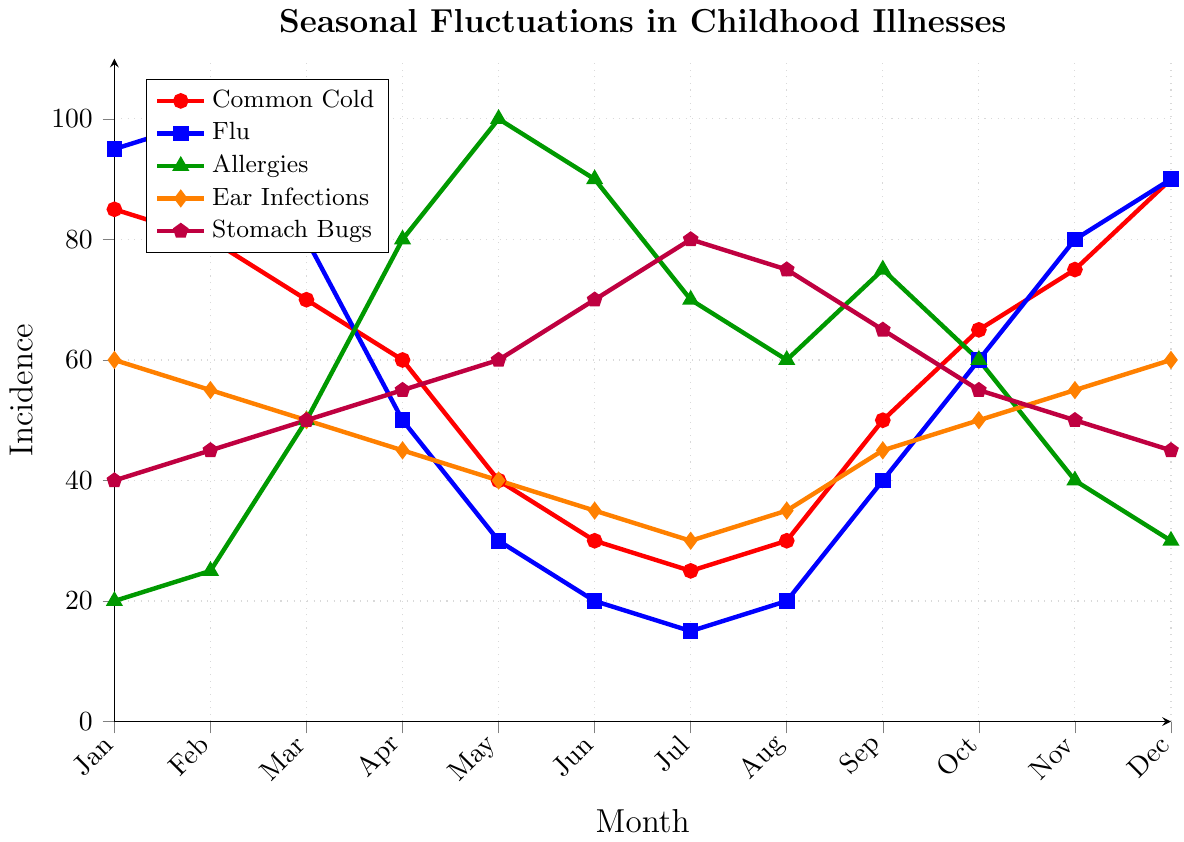Which illness has the highest incidence in February? Look for the peak points in February. The illness with the highest value is the one with the highest incidence. The Flu reaches 100, which is the highest among the illnesses.
Answer: Flu Which two illnesses have the lowest incidence in July? Check the values for each illness in July and identify the two lowest ones. Stomach Bugs have 80 and Common Cold has 25. Common Cold and Flu have the lowest at 25 and 15 respectively.
Answer: Common Cold, Flu Which illness shows the most significant increase from April to May? Compare the values for each illness between April and May and identify the one with the largest increase. Allergies increase from 80 to 100, a 20-point rise, making it the most significant increase.
Answer: Allergies How many illnesses peak in December? Observe the entire range of the data for each illness and see if December has the maximum value for any of them. The Common Cold, Flu, and Ear Infections have their highest values in December.
Answer: Three Is the incidence of Stomach Bugs higher in May or October? Compare the values of Stomach Bugs in May (60) and October (55).
Answer: May What is the trend for Ear Infections throughout the year? Follow the graph of Ear Infections from January to December. The values oscillate but generally start at 60, dip mid-year to 30 but then rise back to 60 by December.
Answer: Fluctuating Which illness has the smallest variation in incidence values? Evaluate the range for each illness by comparing max and min values. Ear Infections vary only from 30 to 60, making it the smallest variation.
Answer: Ear Infections Are Allergies more prevalent in the spring (March-May) or the summer (June-August)? Sum the values for Allergies in March, April, and May compared to June, July, and August. Spring: 50+80+100 = 230; Summer: 90+70+60 = 220.
Answer: Spring What is the average incidence of the common cold across all months? Add up all values for the common cold and divide by 12. (85+80+70+60+40+30+25+30+50+65+75+90) / 12 = 55
Answer: 55 Which month shows the highest combined incidence of all illnesses? Sum up the values for each illness across each month and identify the highest total. December has the highest combined incidence of 275.
Answer: December 